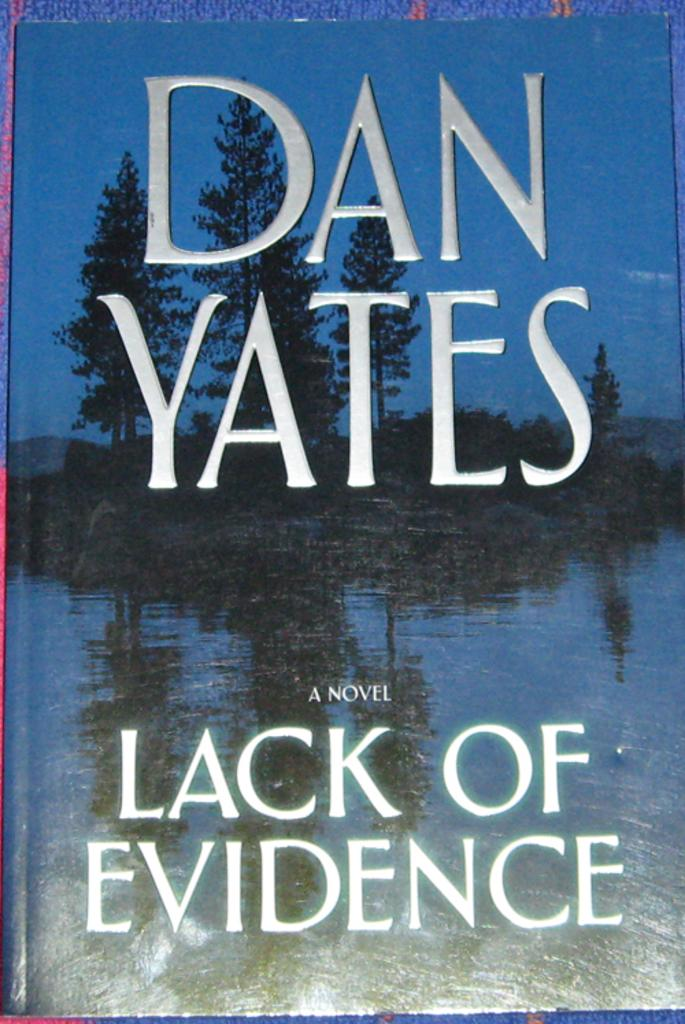Provide a one-sentence caption for the provided image. A book by a Dan Yates called Lack of Evidence. 